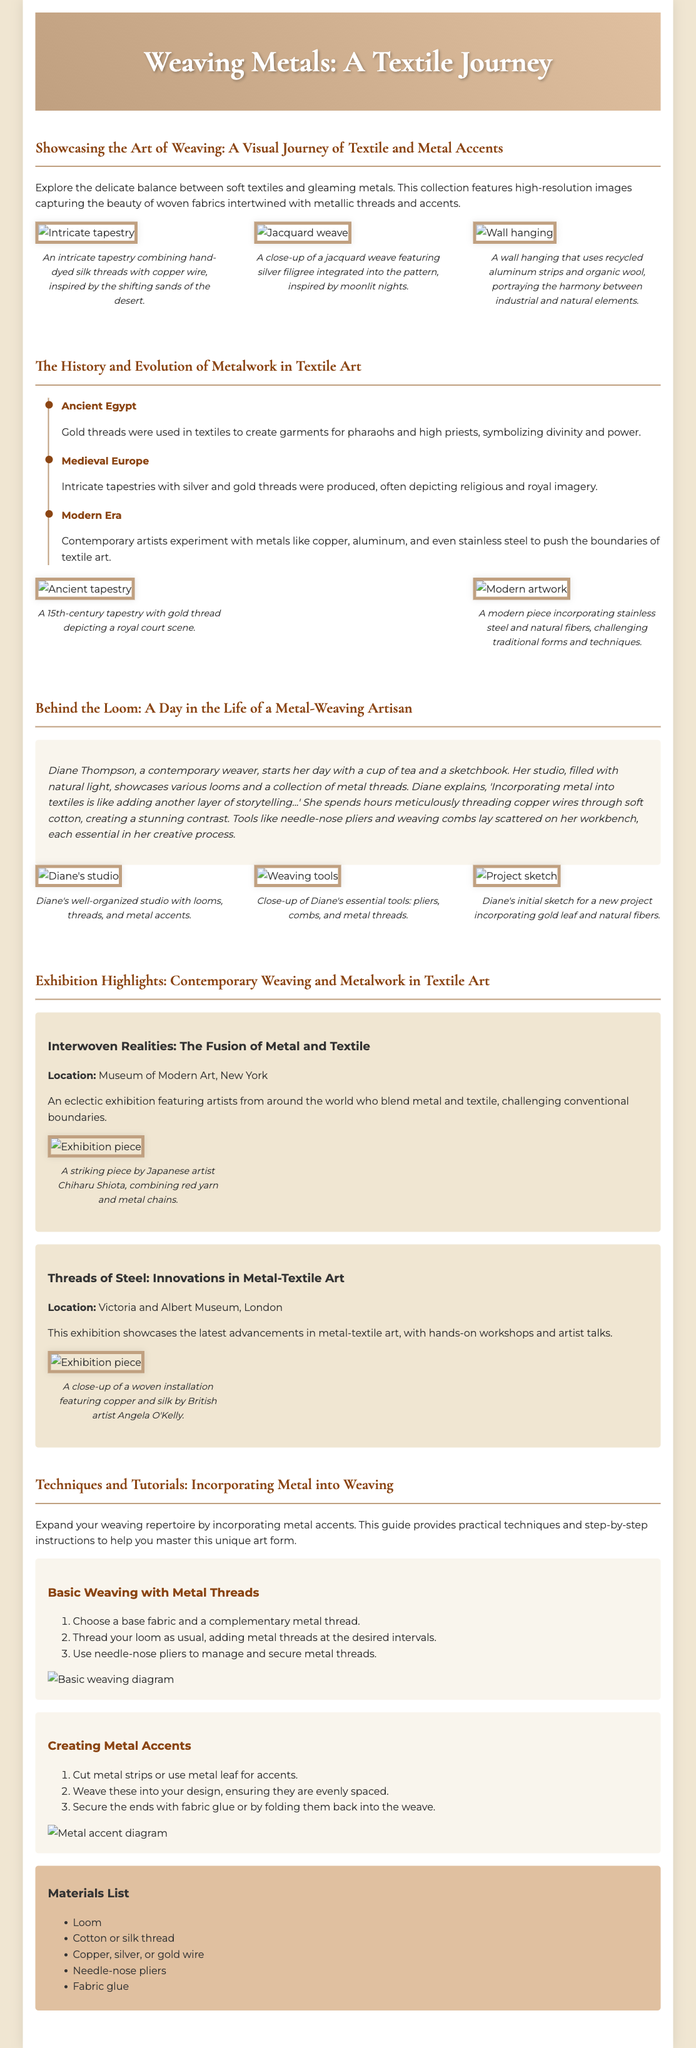What is the title of the exhibition highlighted in New York? The exhibition title is explicitly mentioned in the document under the exhibition highlights section.
Answer: Interwoven Realities: The Fusion of Metal and Textile How many sections are included in the Playbill? The number of sections can be counted based on the headings in the document.
Answer: Five Who is the artisan featured in the section "Behind the Loom"? The document specifies the name of the artisan in the narrative account.
Answer: Diane Thompson What historical period involved the use of gold threads in Egypt? The timeline provides specific historical information about the use of gold in textiles.
Answer: Ancient Egypt What materials are mentioned in the materials list? The materials list outlines various elements required for weaving, which is clearly stated in the document.
Answer: Loom, Cotton or silk thread, Copper, silver, or gold wire, Needle-nose pliers, Fabric glue Which metal is incorporated into the wall hanging that portrays harmony between industrial and natural elements? The description in the image gallery clarifies the specific metal used in that artwork.
Answer: Aluminum What color is the timeline border in the history section? The color of the timeline border is described in the styling section of the document.
Answer: Brown What type of weaving technique is outlined in the practical guide? The document specifies the technique in the tutorial section, indicating what is being taught.
Answer: Basic Weaving with Metal Threads 